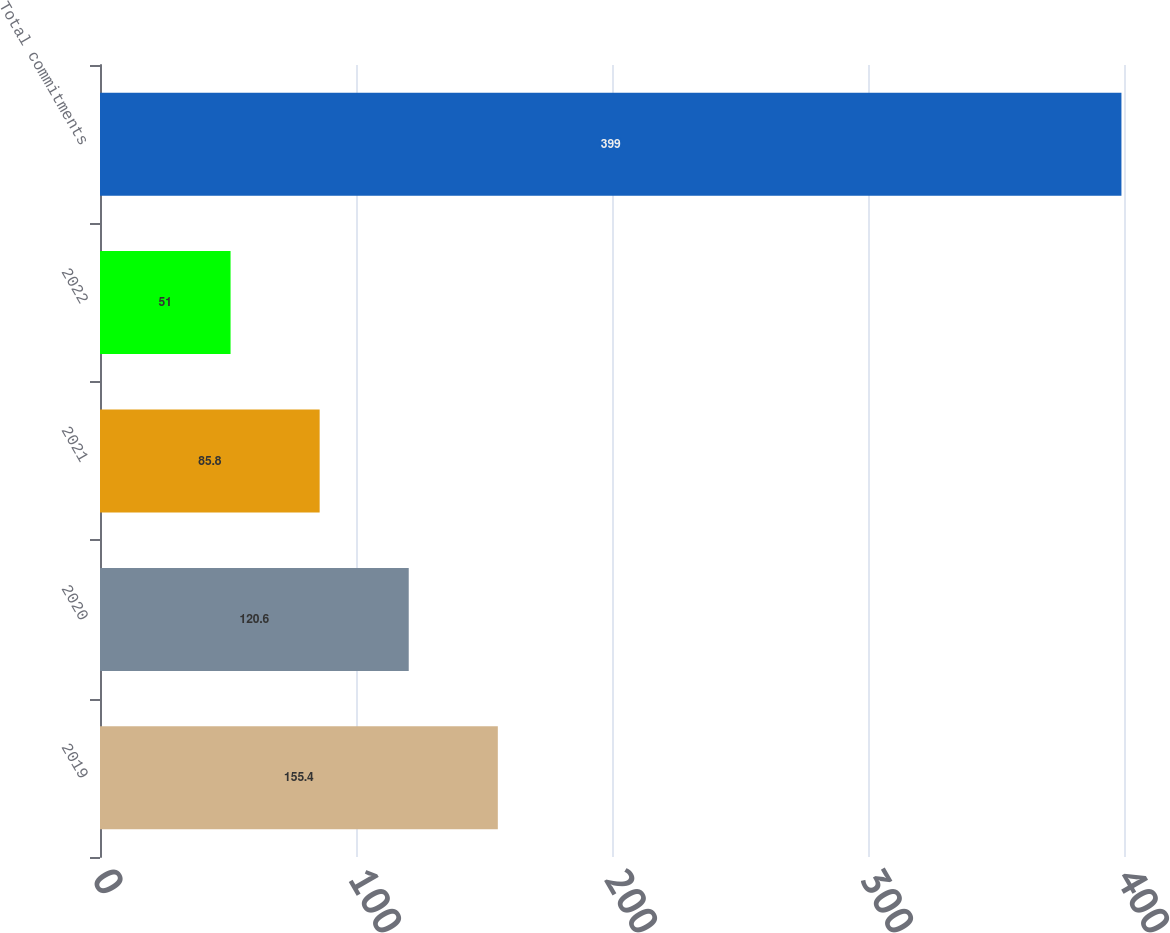Convert chart to OTSL. <chart><loc_0><loc_0><loc_500><loc_500><bar_chart><fcel>2019<fcel>2020<fcel>2021<fcel>2022<fcel>Total commitments<nl><fcel>155.4<fcel>120.6<fcel>85.8<fcel>51<fcel>399<nl></chart> 